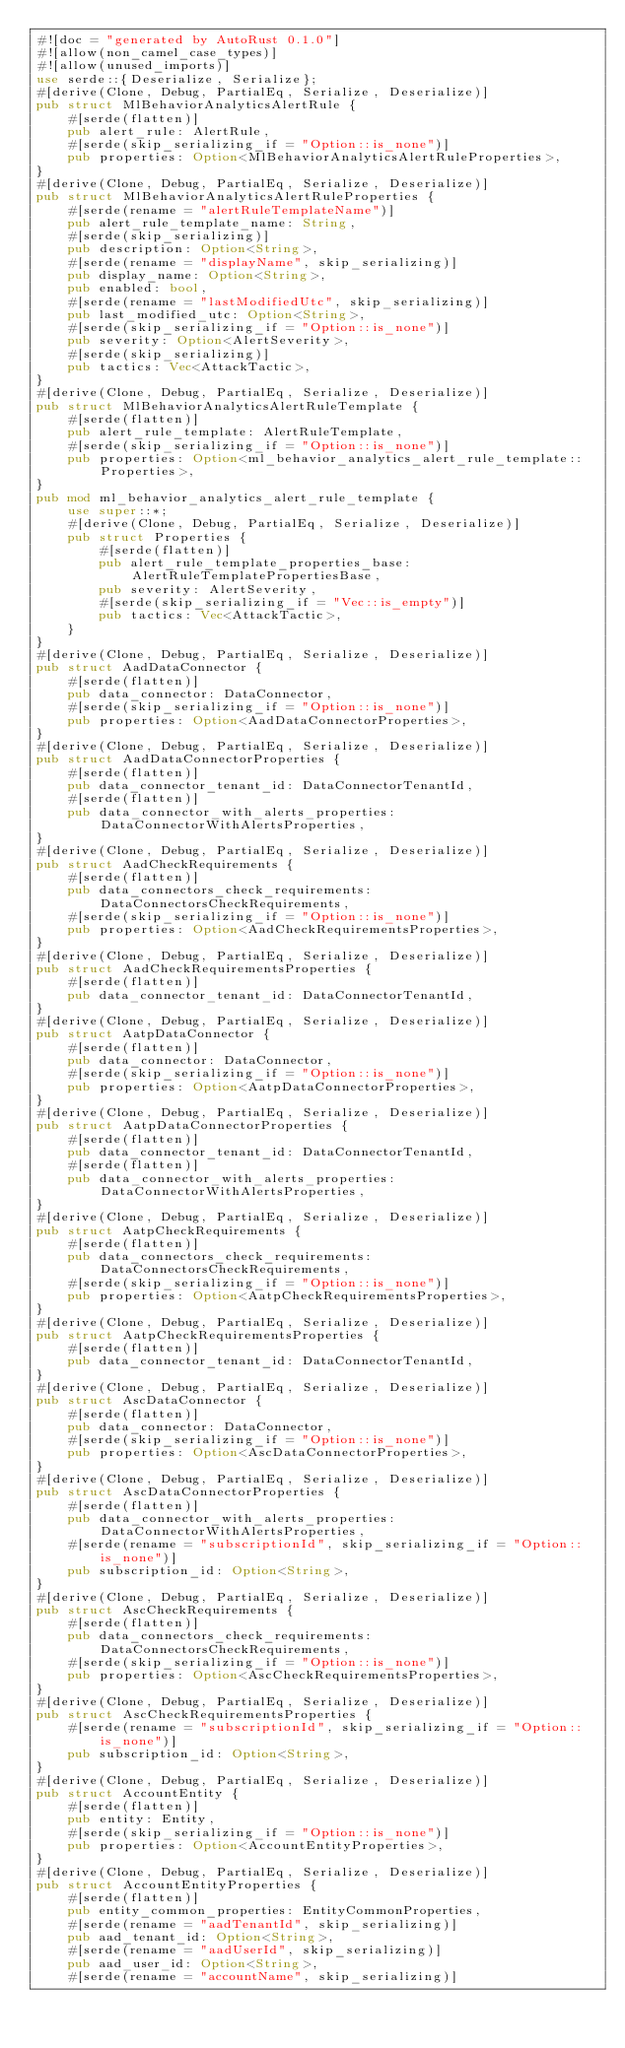Convert code to text. <code><loc_0><loc_0><loc_500><loc_500><_Rust_>#![doc = "generated by AutoRust 0.1.0"]
#![allow(non_camel_case_types)]
#![allow(unused_imports)]
use serde::{Deserialize, Serialize};
#[derive(Clone, Debug, PartialEq, Serialize, Deserialize)]
pub struct MlBehaviorAnalyticsAlertRule {
    #[serde(flatten)]
    pub alert_rule: AlertRule,
    #[serde(skip_serializing_if = "Option::is_none")]
    pub properties: Option<MlBehaviorAnalyticsAlertRuleProperties>,
}
#[derive(Clone, Debug, PartialEq, Serialize, Deserialize)]
pub struct MlBehaviorAnalyticsAlertRuleProperties {
    #[serde(rename = "alertRuleTemplateName")]
    pub alert_rule_template_name: String,
    #[serde(skip_serializing)]
    pub description: Option<String>,
    #[serde(rename = "displayName", skip_serializing)]
    pub display_name: Option<String>,
    pub enabled: bool,
    #[serde(rename = "lastModifiedUtc", skip_serializing)]
    pub last_modified_utc: Option<String>,
    #[serde(skip_serializing_if = "Option::is_none")]
    pub severity: Option<AlertSeverity>,
    #[serde(skip_serializing)]
    pub tactics: Vec<AttackTactic>,
}
#[derive(Clone, Debug, PartialEq, Serialize, Deserialize)]
pub struct MlBehaviorAnalyticsAlertRuleTemplate {
    #[serde(flatten)]
    pub alert_rule_template: AlertRuleTemplate,
    #[serde(skip_serializing_if = "Option::is_none")]
    pub properties: Option<ml_behavior_analytics_alert_rule_template::Properties>,
}
pub mod ml_behavior_analytics_alert_rule_template {
    use super::*;
    #[derive(Clone, Debug, PartialEq, Serialize, Deserialize)]
    pub struct Properties {
        #[serde(flatten)]
        pub alert_rule_template_properties_base: AlertRuleTemplatePropertiesBase,
        pub severity: AlertSeverity,
        #[serde(skip_serializing_if = "Vec::is_empty")]
        pub tactics: Vec<AttackTactic>,
    }
}
#[derive(Clone, Debug, PartialEq, Serialize, Deserialize)]
pub struct AadDataConnector {
    #[serde(flatten)]
    pub data_connector: DataConnector,
    #[serde(skip_serializing_if = "Option::is_none")]
    pub properties: Option<AadDataConnectorProperties>,
}
#[derive(Clone, Debug, PartialEq, Serialize, Deserialize)]
pub struct AadDataConnectorProperties {
    #[serde(flatten)]
    pub data_connector_tenant_id: DataConnectorTenantId,
    #[serde(flatten)]
    pub data_connector_with_alerts_properties: DataConnectorWithAlertsProperties,
}
#[derive(Clone, Debug, PartialEq, Serialize, Deserialize)]
pub struct AadCheckRequirements {
    #[serde(flatten)]
    pub data_connectors_check_requirements: DataConnectorsCheckRequirements,
    #[serde(skip_serializing_if = "Option::is_none")]
    pub properties: Option<AadCheckRequirementsProperties>,
}
#[derive(Clone, Debug, PartialEq, Serialize, Deserialize)]
pub struct AadCheckRequirementsProperties {
    #[serde(flatten)]
    pub data_connector_tenant_id: DataConnectorTenantId,
}
#[derive(Clone, Debug, PartialEq, Serialize, Deserialize)]
pub struct AatpDataConnector {
    #[serde(flatten)]
    pub data_connector: DataConnector,
    #[serde(skip_serializing_if = "Option::is_none")]
    pub properties: Option<AatpDataConnectorProperties>,
}
#[derive(Clone, Debug, PartialEq, Serialize, Deserialize)]
pub struct AatpDataConnectorProperties {
    #[serde(flatten)]
    pub data_connector_tenant_id: DataConnectorTenantId,
    #[serde(flatten)]
    pub data_connector_with_alerts_properties: DataConnectorWithAlertsProperties,
}
#[derive(Clone, Debug, PartialEq, Serialize, Deserialize)]
pub struct AatpCheckRequirements {
    #[serde(flatten)]
    pub data_connectors_check_requirements: DataConnectorsCheckRequirements,
    #[serde(skip_serializing_if = "Option::is_none")]
    pub properties: Option<AatpCheckRequirementsProperties>,
}
#[derive(Clone, Debug, PartialEq, Serialize, Deserialize)]
pub struct AatpCheckRequirementsProperties {
    #[serde(flatten)]
    pub data_connector_tenant_id: DataConnectorTenantId,
}
#[derive(Clone, Debug, PartialEq, Serialize, Deserialize)]
pub struct AscDataConnector {
    #[serde(flatten)]
    pub data_connector: DataConnector,
    #[serde(skip_serializing_if = "Option::is_none")]
    pub properties: Option<AscDataConnectorProperties>,
}
#[derive(Clone, Debug, PartialEq, Serialize, Deserialize)]
pub struct AscDataConnectorProperties {
    #[serde(flatten)]
    pub data_connector_with_alerts_properties: DataConnectorWithAlertsProperties,
    #[serde(rename = "subscriptionId", skip_serializing_if = "Option::is_none")]
    pub subscription_id: Option<String>,
}
#[derive(Clone, Debug, PartialEq, Serialize, Deserialize)]
pub struct AscCheckRequirements {
    #[serde(flatten)]
    pub data_connectors_check_requirements: DataConnectorsCheckRequirements,
    #[serde(skip_serializing_if = "Option::is_none")]
    pub properties: Option<AscCheckRequirementsProperties>,
}
#[derive(Clone, Debug, PartialEq, Serialize, Deserialize)]
pub struct AscCheckRequirementsProperties {
    #[serde(rename = "subscriptionId", skip_serializing_if = "Option::is_none")]
    pub subscription_id: Option<String>,
}
#[derive(Clone, Debug, PartialEq, Serialize, Deserialize)]
pub struct AccountEntity {
    #[serde(flatten)]
    pub entity: Entity,
    #[serde(skip_serializing_if = "Option::is_none")]
    pub properties: Option<AccountEntityProperties>,
}
#[derive(Clone, Debug, PartialEq, Serialize, Deserialize)]
pub struct AccountEntityProperties {
    #[serde(flatten)]
    pub entity_common_properties: EntityCommonProperties,
    #[serde(rename = "aadTenantId", skip_serializing)]
    pub aad_tenant_id: Option<String>,
    #[serde(rename = "aadUserId", skip_serializing)]
    pub aad_user_id: Option<String>,
    #[serde(rename = "accountName", skip_serializing)]</code> 